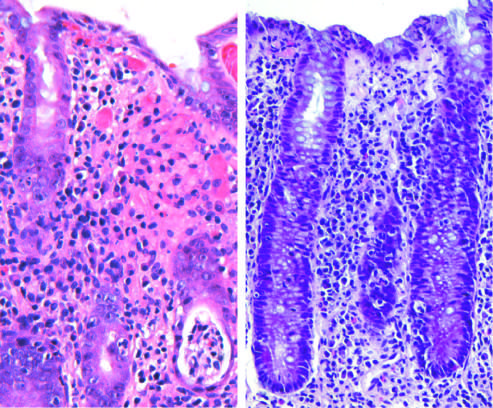does the wall of the aneurysm produce acute, self-limited colitis?
Answer the question using a single word or phrase. No 